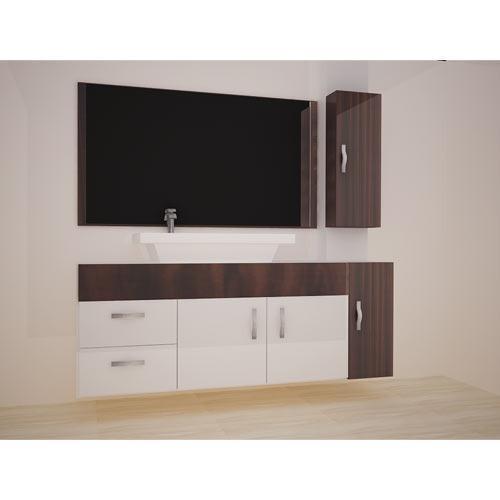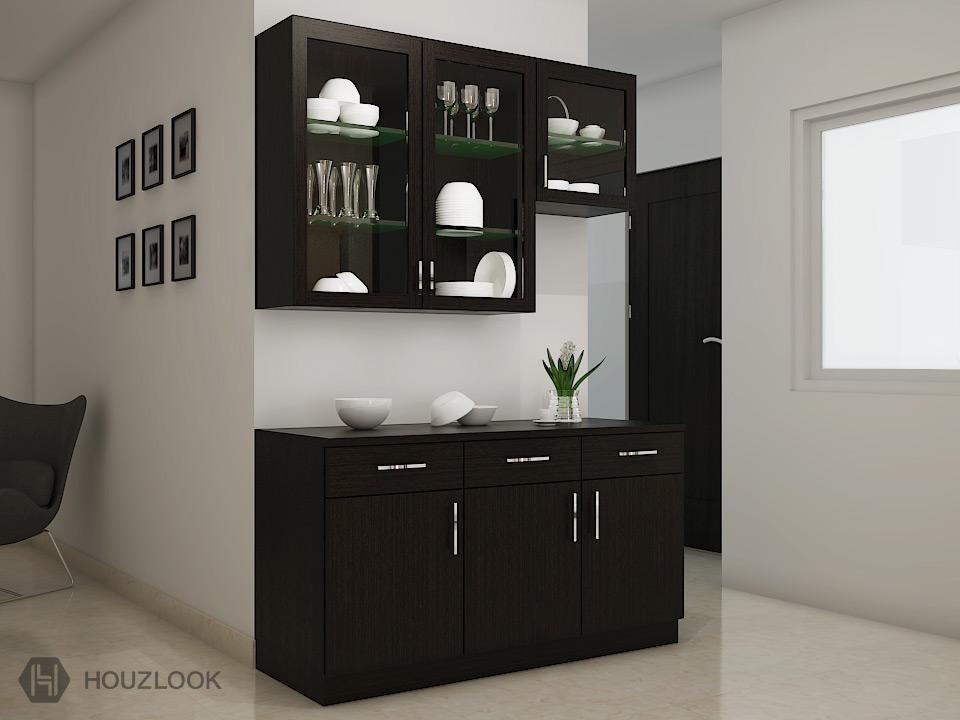The first image is the image on the left, the second image is the image on the right. Evaluate the accuracy of this statement regarding the images: "The right image shows glass-fronted black cabinets mounted on the wall above a counter with black cabinets that sits on the floor.". Is it true? Answer yes or no. Yes. The first image is the image on the left, the second image is the image on the right. Considering the images on both sides, is "Atleast one picture has black cabinets." valid? Answer yes or no. Yes. 